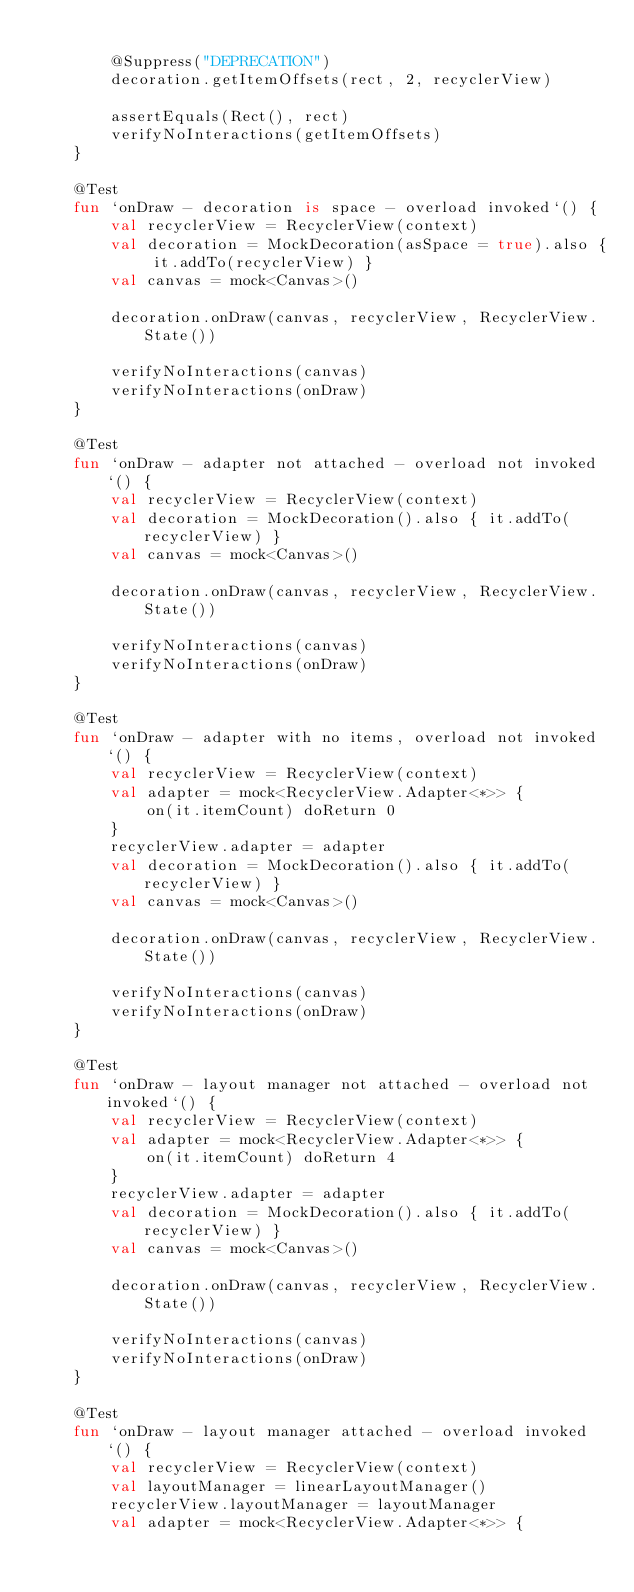<code> <loc_0><loc_0><loc_500><loc_500><_Kotlin_>
        @Suppress("DEPRECATION")
        decoration.getItemOffsets(rect, 2, recyclerView)

        assertEquals(Rect(), rect)
        verifyNoInteractions(getItemOffsets)
    }

    @Test
    fun `onDraw - decoration is space - overload invoked`() {
        val recyclerView = RecyclerView(context)
        val decoration = MockDecoration(asSpace = true).also { it.addTo(recyclerView) }
        val canvas = mock<Canvas>()

        decoration.onDraw(canvas, recyclerView, RecyclerView.State())

        verifyNoInteractions(canvas)
        verifyNoInteractions(onDraw)
    }

    @Test
    fun `onDraw - adapter not attached - overload not invoked`() {
        val recyclerView = RecyclerView(context)
        val decoration = MockDecoration().also { it.addTo(recyclerView) }
        val canvas = mock<Canvas>()

        decoration.onDraw(canvas, recyclerView, RecyclerView.State())

        verifyNoInteractions(canvas)
        verifyNoInteractions(onDraw)
    }

    @Test
    fun `onDraw - adapter with no items, overload not invoked`() {
        val recyclerView = RecyclerView(context)
        val adapter = mock<RecyclerView.Adapter<*>> {
            on(it.itemCount) doReturn 0
        }
        recyclerView.adapter = adapter
        val decoration = MockDecoration().also { it.addTo(recyclerView) }
        val canvas = mock<Canvas>()

        decoration.onDraw(canvas, recyclerView, RecyclerView.State())

        verifyNoInteractions(canvas)
        verifyNoInteractions(onDraw)
    }

    @Test
    fun `onDraw - layout manager not attached - overload not invoked`() {
        val recyclerView = RecyclerView(context)
        val adapter = mock<RecyclerView.Adapter<*>> {
            on(it.itemCount) doReturn 4
        }
        recyclerView.adapter = adapter
        val decoration = MockDecoration().also { it.addTo(recyclerView) }
        val canvas = mock<Canvas>()

        decoration.onDraw(canvas, recyclerView, RecyclerView.State())

        verifyNoInteractions(canvas)
        verifyNoInteractions(onDraw)
    }

    @Test
    fun `onDraw - layout manager attached - overload invoked`() {
        val recyclerView = RecyclerView(context)
        val layoutManager = linearLayoutManager()
        recyclerView.layoutManager = layoutManager
        val adapter = mock<RecyclerView.Adapter<*>> {</code> 